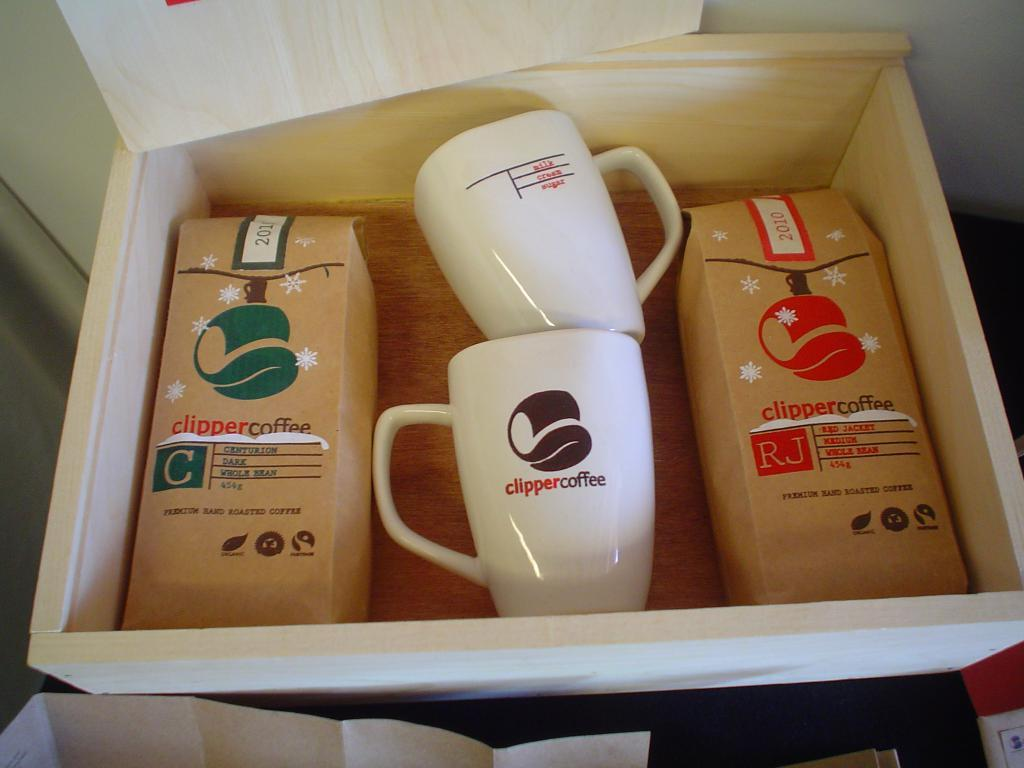<image>
Relay a brief, clear account of the picture shown. A gift box contains coffee and coffee mugs from the brand ClipperCoffee. 